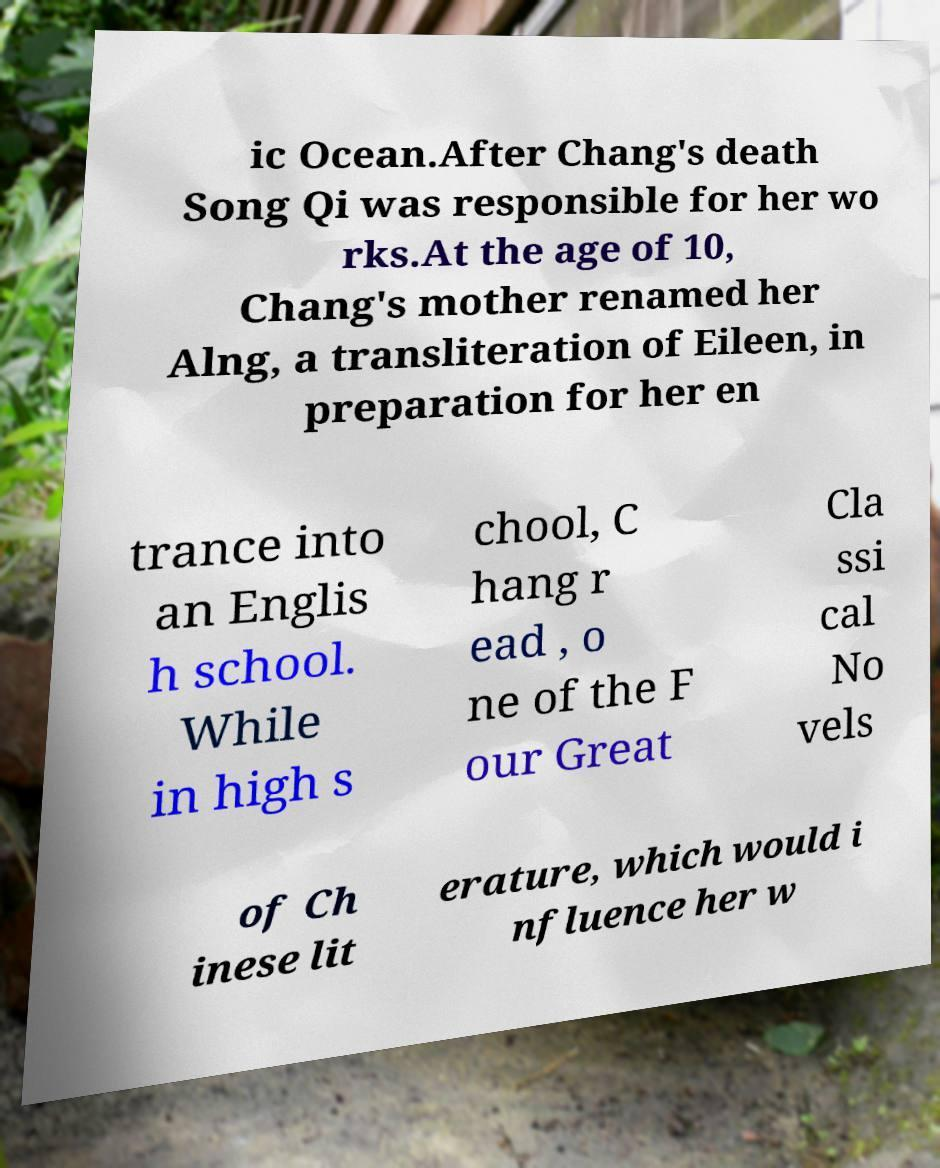Please identify and transcribe the text found in this image. ic Ocean.After Chang's death Song Qi was responsible for her wo rks.At the age of 10, Chang's mother renamed her Alng, a transliteration of Eileen, in preparation for her en trance into an Englis h school. While in high s chool, C hang r ead , o ne of the F our Great Cla ssi cal No vels of Ch inese lit erature, which would i nfluence her w 